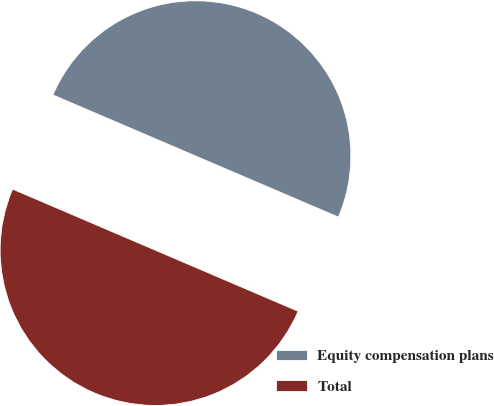Convert chart. <chart><loc_0><loc_0><loc_500><loc_500><pie_chart><fcel>Equity compensation plans<fcel>Total<nl><fcel>50.0%<fcel>50.0%<nl></chart> 